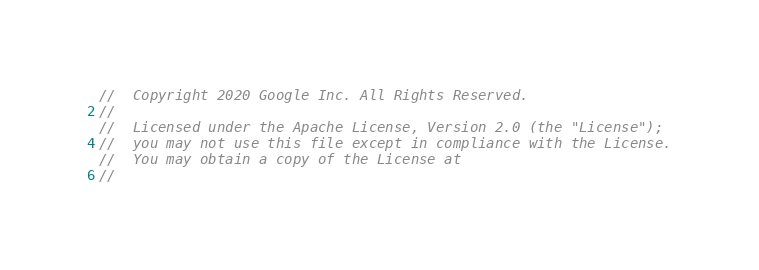<code> <loc_0><loc_0><loc_500><loc_500><_Go_>//  Copyright 2020 Google Inc. All Rights Reserved.
//
//  Licensed under the Apache License, Version 2.0 (the "License");
//  you may not use this file except in compliance with the License.
//  You may obtain a copy of the License at
//</code> 